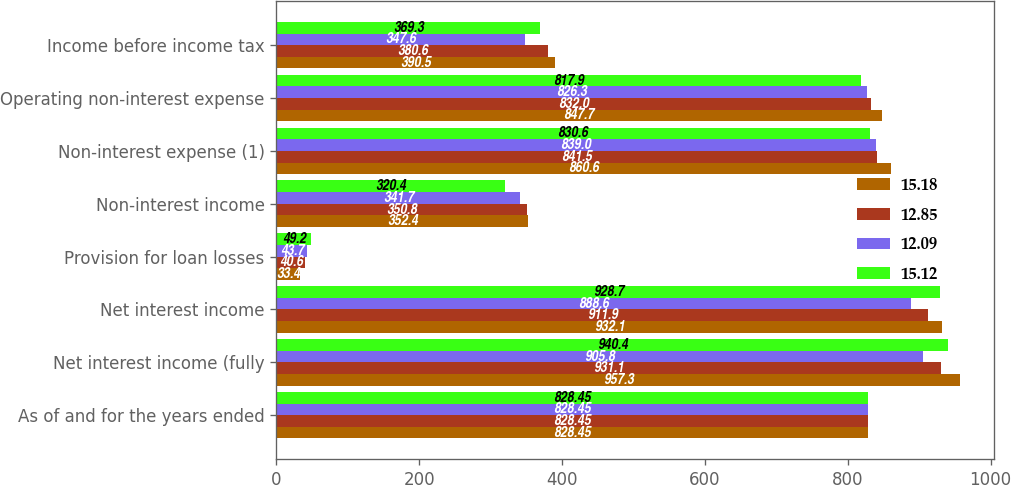<chart> <loc_0><loc_0><loc_500><loc_500><stacked_bar_chart><ecel><fcel>As of and for the years ended<fcel>Net interest income (fully<fcel>Net interest income<fcel>Provision for loan losses<fcel>Non-interest income<fcel>Non-interest expense (1)<fcel>Operating non-interest expense<fcel>Income before income tax<nl><fcel>15.18<fcel>828.45<fcel>957.3<fcel>932.1<fcel>33.4<fcel>352.4<fcel>860.6<fcel>847.7<fcel>390.5<nl><fcel>12.85<fcel>828.45<fcel>931.1<fcel>911.9<fcel>40.6<fcel>350.8<fcel>841.5<fcel>832<fcel>380.6<nl><fcel>12.09<fcel>828.45<fcel>905.8<fcel>888.6<fcel>43.7<fcel>341.7<fcel>839<fcel>826.3<fcel>347.6<nl><fcel>15.12<fcel>828.45<fcel>940.4<fcel>928.7<fcel>49.2<fcel>320.4<fcel>830.6<fcel>817.9<fcel>369.3<nl></chart> 